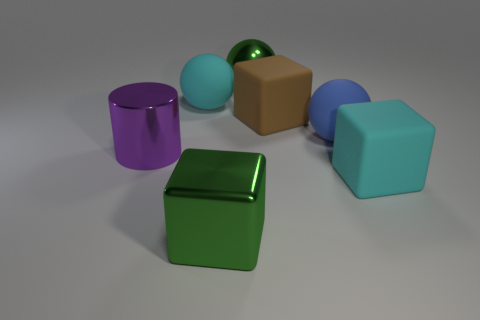Imagine these objects are part of a game. What could be the rules based on their shapes and colors? In a game setting, these objects could represent different elements or resources. For example, each shape could have a unique ability or role: cubes could be building blocks, spheres might be used for trading, and cylinders could be energy sources. The different colors could correspond to different rarity levels or elements - cyan could be water, green could be earth, and purple could signify magic. The goal might be to collect and strategically use these objects to build structures, gain powers, or complete challenges. 